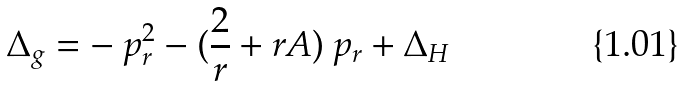<formula> <loc_0><loc_0><loc_500><loc_500>\Delta _ { g } = - \ p _ { r } ^ { 2 } - ( \frac { 2 } { r } + r A ) \ p _ { r } + \Delta _ { H }</formula> 